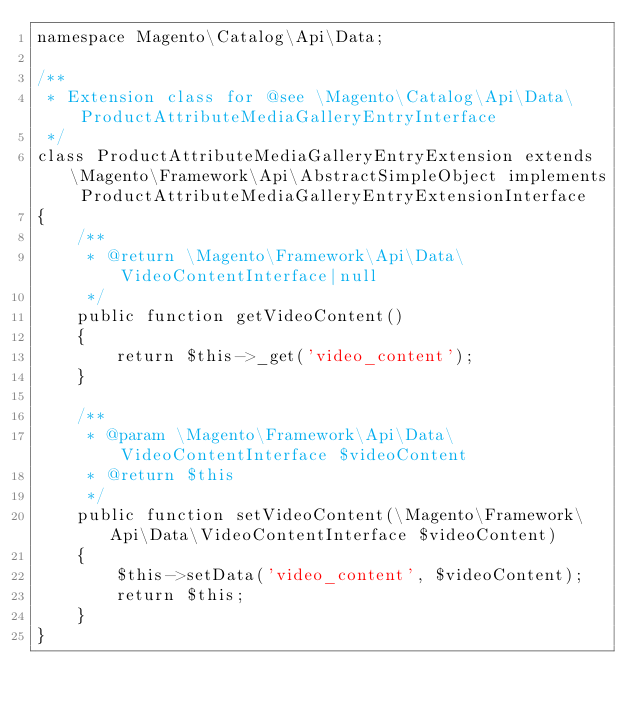<code> <loc_0><loc_0><loc_500><loc_500><_PHP_>namespace Magento\Catalog\Api\Data;

/**
 * Extension class for @see \Magento\Catalog\Api\Data\ProductAttributeMediaGalleryEntryInterface
 */
class ProductAttributeMediaGalleryEntryExtension extends \Magento\Framework\Api\AbstractSimpleObject implements ProductAttributeMediaGalleryEntryExtensionInterface
{
    /**
     * @return \Magento\Framework\Api\Data\VideoContentInterface|null
     */
    public function getVideoContent()
    {
        return $this->_get('video_content');
    }

    /**
     * @param \Magento\Framework\Api\Data\VideoContentInterface $videoContent
     * @return $this
     */
    public function setVideoContent(\Magento\Framework\Api\Data\VideoContentInterface $videoContent)
    {
        $this->setData('video_content', $videoContent);
        return $this;
    }
}
</code> 